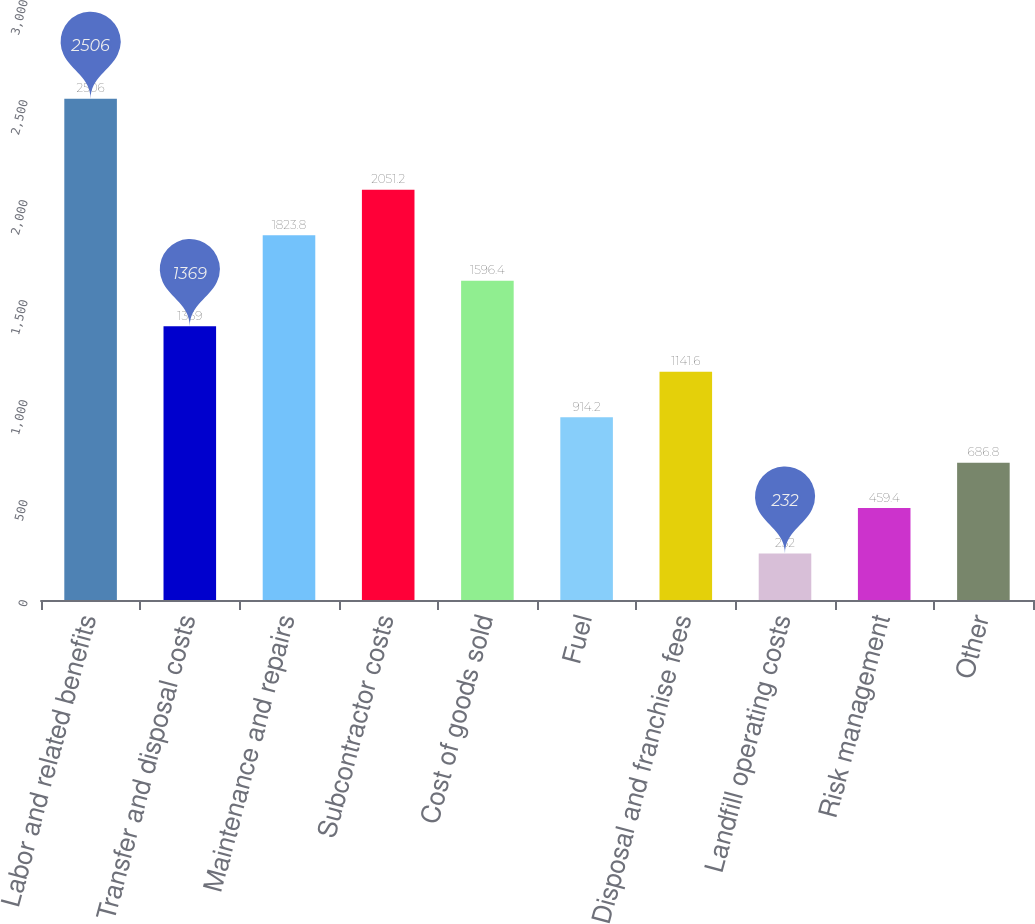Convert chart. <chart><loc_0><loc_0><loc_500><loc_500><bar_chart><fcel>Labor and related benefits<fcel>Transfer and disposal costs<fcel>Maintenance and repairs<fcel>Subcontractor costs<fcel>Cost of goods sold<fcel>Fuel<fcel>Disposal and franchise fees<fcel>Landfill operating costs<fcel>Risk management<fcel>Other<nl><fcel>2506<fcel>1369<fcel>1823.8<fcel>2051.2<fcel>1596.4<fcel>914.2<fcel>1141.6<fcel>232<fcel>459.4<fcel>686.8<nl></chart> 